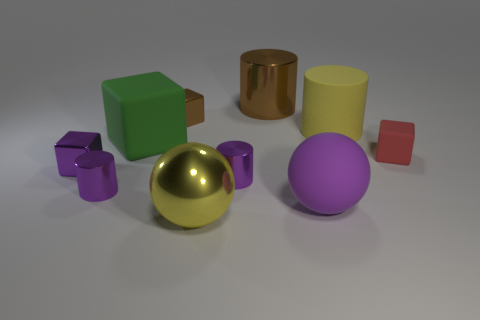The other matte object that is the same shape as the tiny rubber thing is what size?
Provide a succinct answer. Large. The other large object that is the same shape as the yellow matte thing is what color?
Ensure brevity in your answer.  Brown. There is a purple cube; does it have the same size as the thing to the right of the big yellow cylinder?
Provide a short and direct response. Yes. What is the size of the brown cube?
Provide a succinct answer. Small. What color is the large ball that is made of the same material as the purple cube?
Keep it short and to the point. Yellow. How many big cubes are the same material as the big brown object?
Give a very brief answer. 0. How many things are either large yellow rubber cylinders or things that are on the left side of the large brown metal cylinder?
Give a very brief answer. 7. Is the big yellow thing behind the purple metal cube made of the same material as the purple block?
Ensure brevity in your answer.  No. What is the color of the other shiny cube that is the same size as the brown block?
Your response must be concise. Purple. Are there any other objects that have the same shape as the small red thing?
Your response must be concise. Yes. 